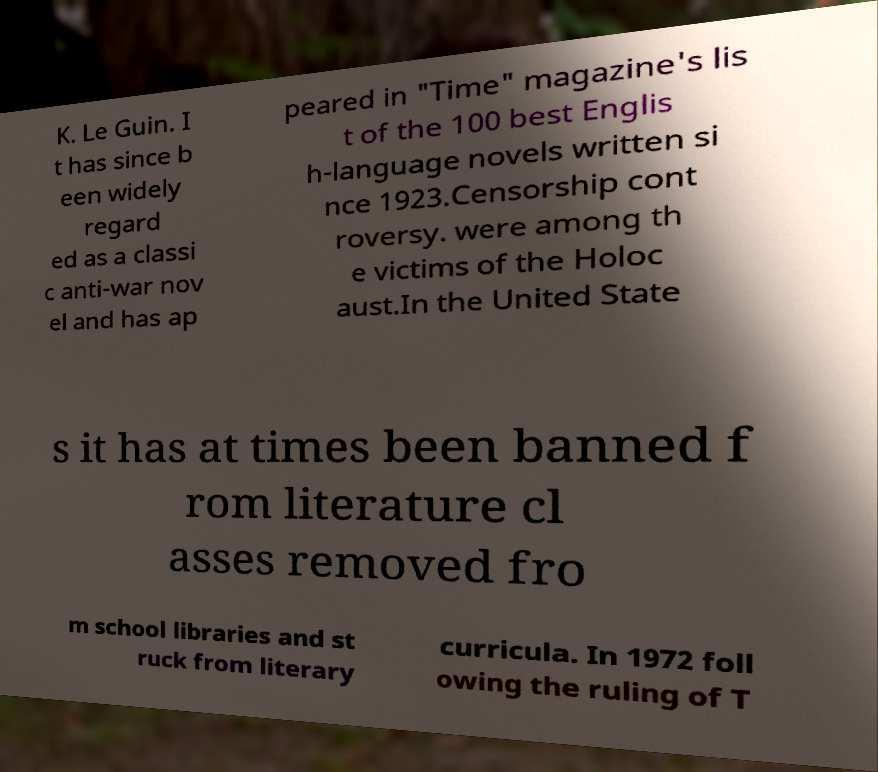What messages or text are displayed in this image? I need them in a readable, typed format. K. Le Guin. I t has since b een widely regard ed as a classi c anti-war nov el and has ap peared in "Time" magazine's lis t of the 100 best Englis h-language novels written si nce 1923.Censorship cont roversy. were among th e victims of the Holoc aust.In the United State s it has at times been banned f rom literature cl asses removed fro m school libraries and st ruck from literary curricula. In 1972 foll owing the ruling of T 